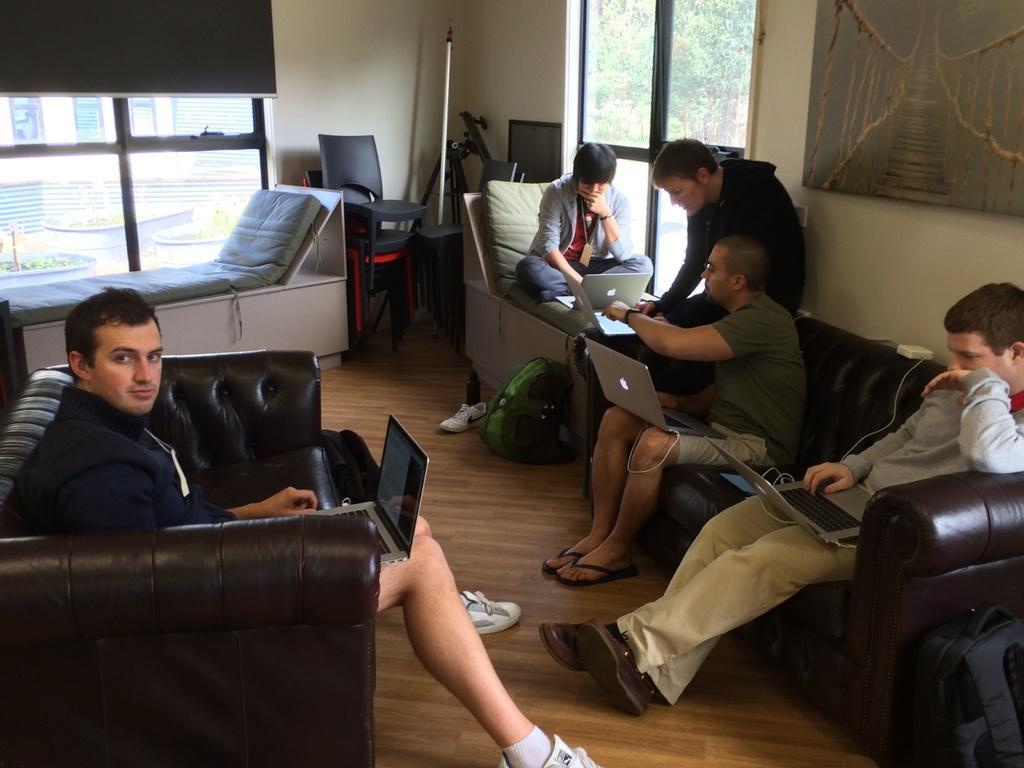Could you give a brief overview of what you see in this image? In the picture we can see inside the house with wooden floor on it, we can see two sofas which are black in color and a few people sitting on it and working on laptops and in the background also we can see a man sitting on the chair and working on the laptop and behind it we can see a wall with two glass windows and into the wall we can see a painting board. 